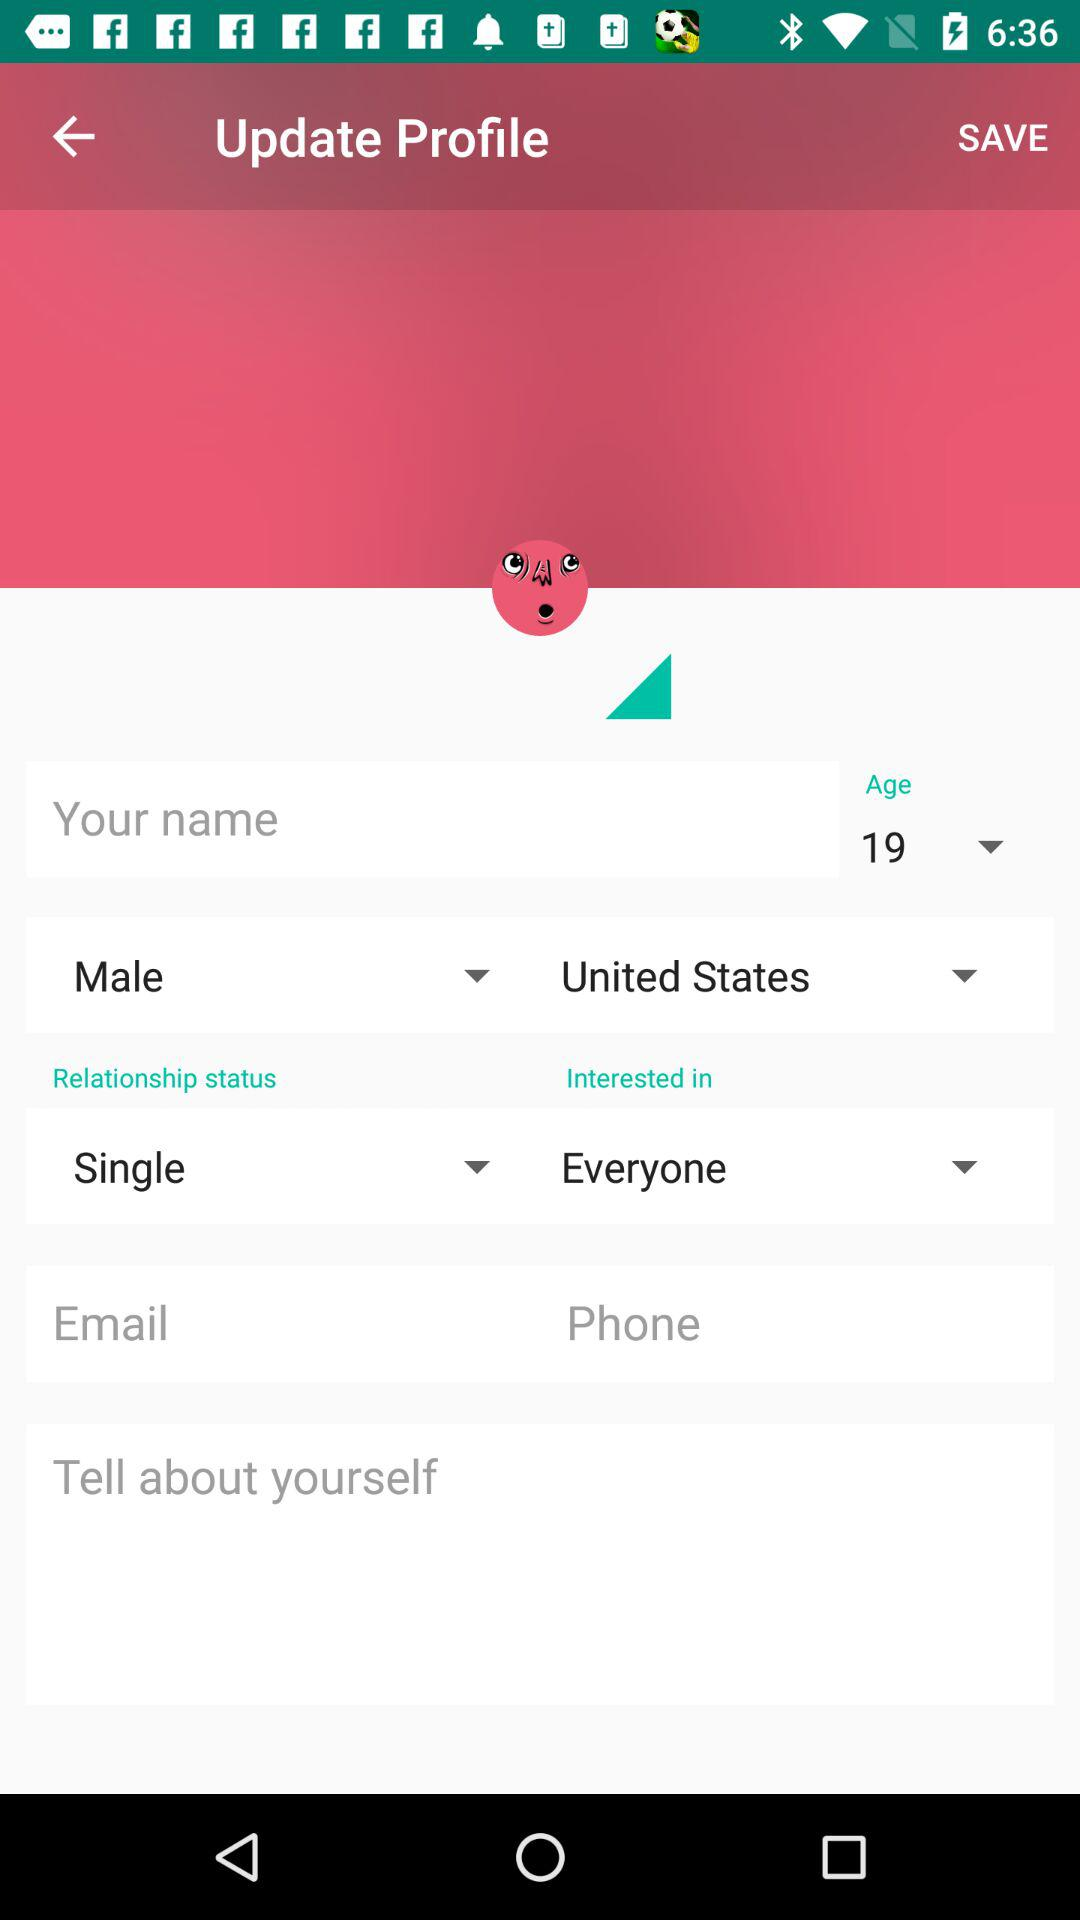To what country does the user belong? The user belongs to the United States. 